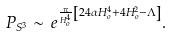Convert formula to latex. <formula><loc_0><loc_0><loc_500><loc_500>P _ { S ^ { 3 } } \sim \, e ^ { \frac { \pi } { H _ { o } ^ { 4 } } \left [ 2 4 \alpha H _ { o } ^ { 4 } + 4 H _ { o } ^ { 2 } - \Lambda \right ] } .</formula> 